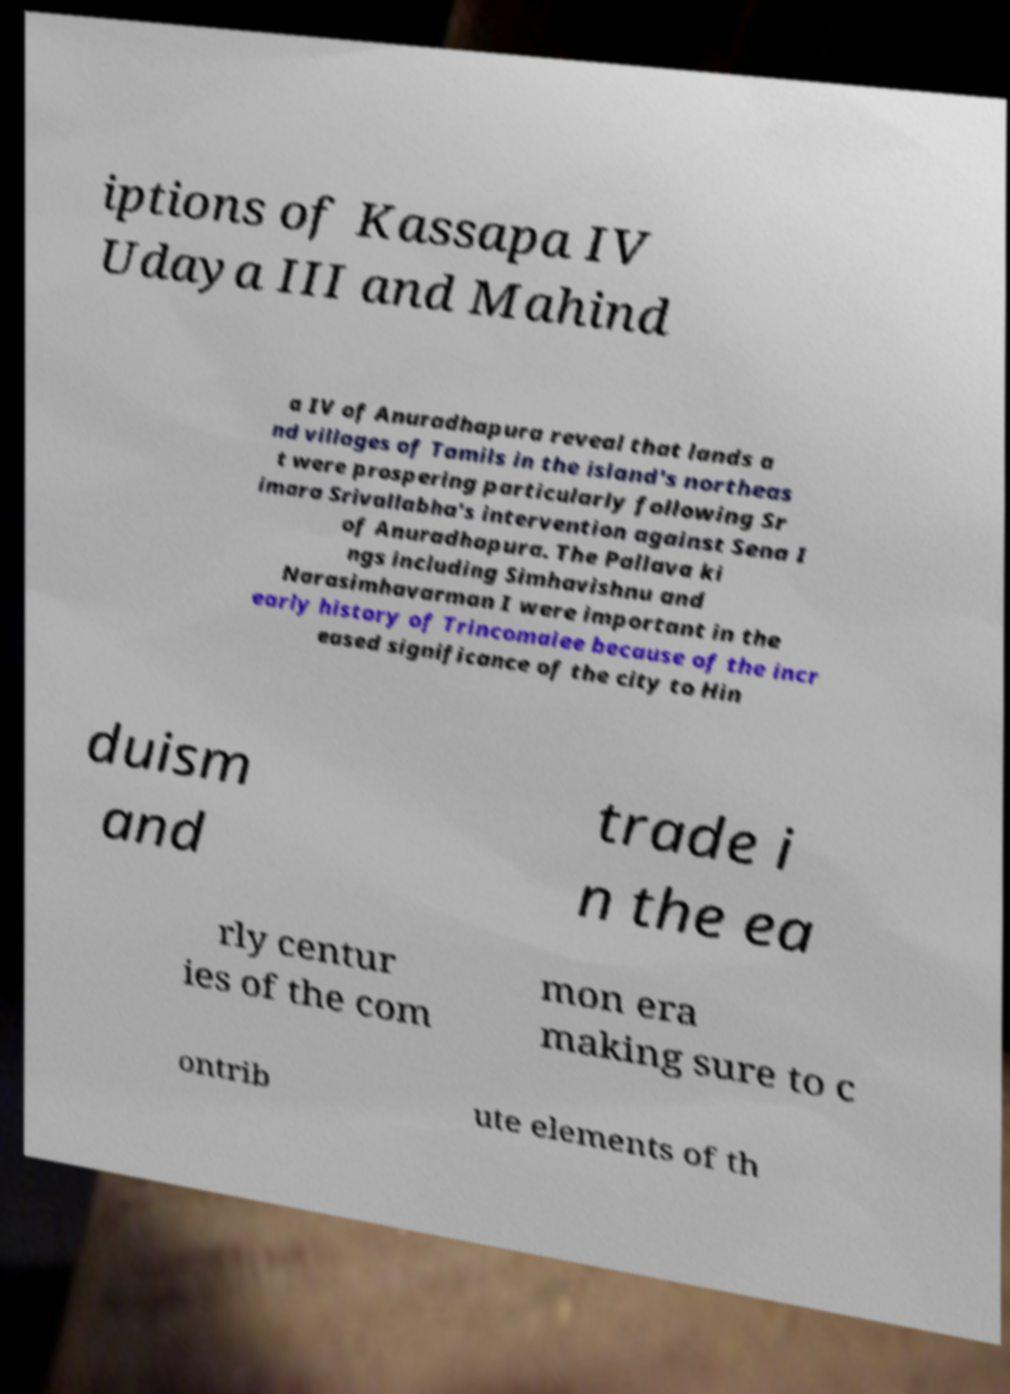Please read and relay the text visible in this image. What does it say? iptions of Kassapa IV Udaya III and Mahind a IV of Anuradhapura reveal that lands a nd villages of Tamils in the island's northeas t were prospering particularly following Sr imara Srivallabha's intervention against Sena I of Anuradhapura. The Pallava ki ngs including Simhavishnu and Narasimhavarman I were important in the early history of Trincomalee because of the incr eased significance of the city to Hin duism and trade i n the ea rly centur ies of the com mon era making sure to c ontrib ute elements of th 